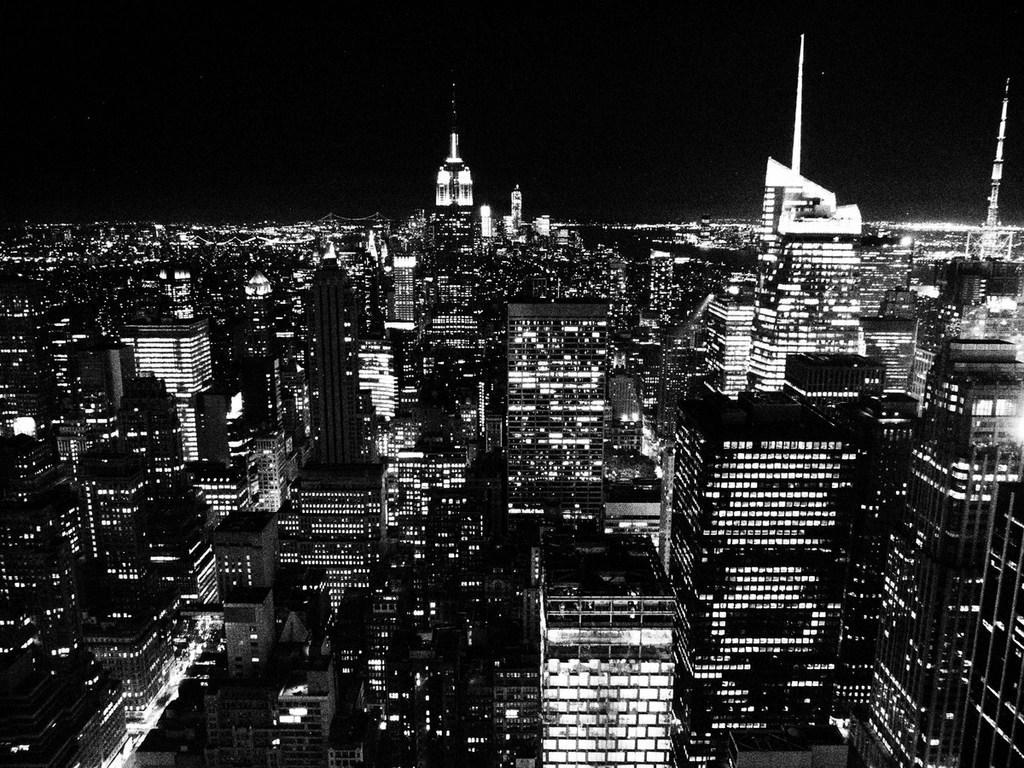In one or two sentences, can you explain what this image depicts? This is a black and white image. There are so many buildings in the middle. There is sky at the top. There are lights in the buildings. 